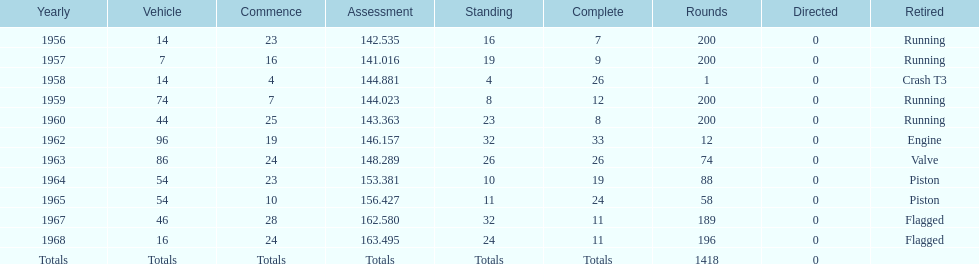Tell me the number of times he finished above 10th place. 3. 